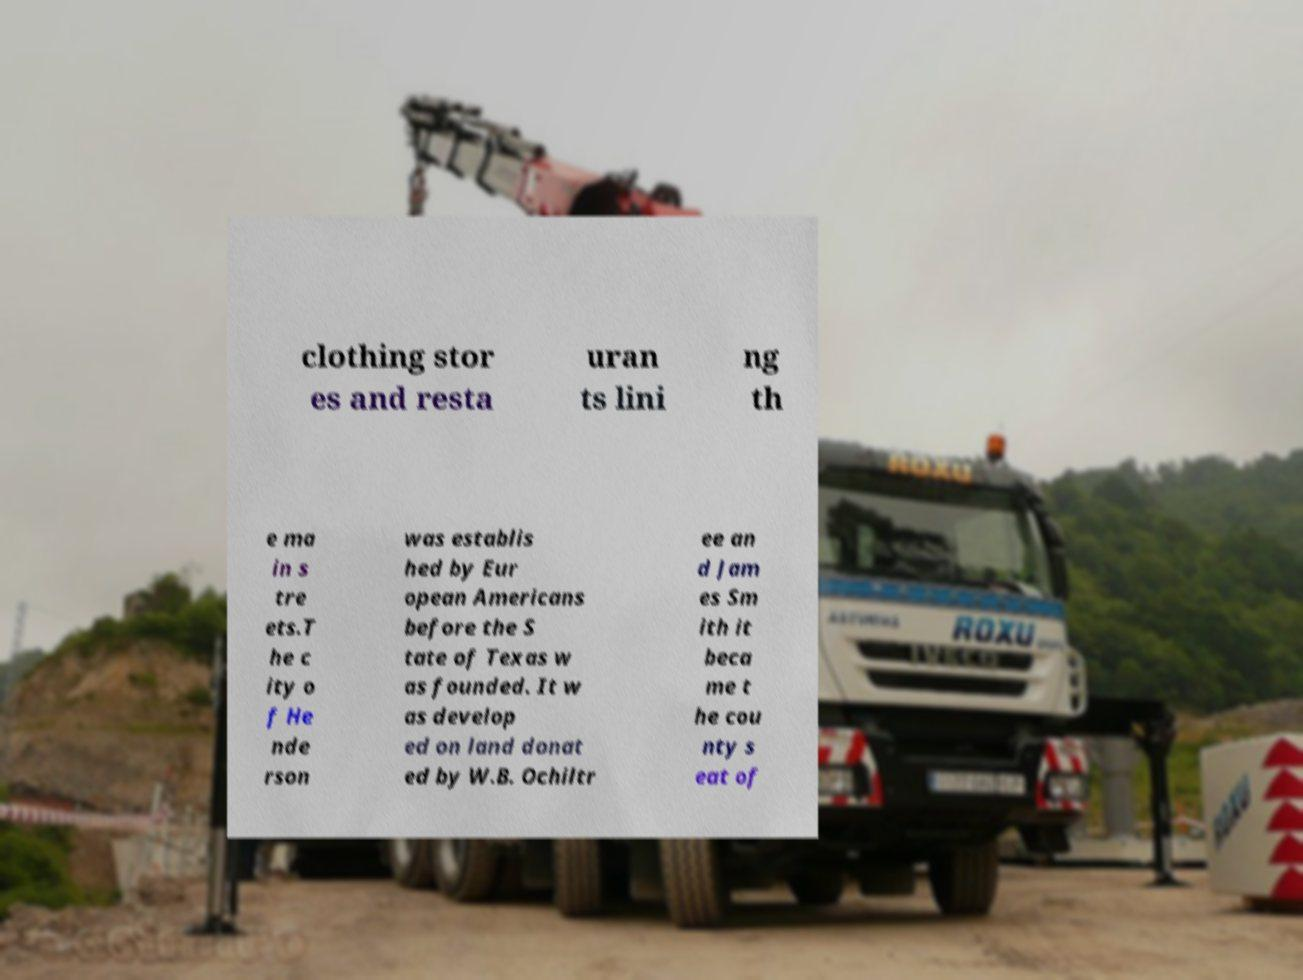For documentation purposes, I need the text within this image transcribed. Could you provide that? clothing stor es and resta uran ts lini ng th e ma in s tre ets.T he c ity o f He nde rson was establis hed by Eur opean Americans before the S tate of Texas w as founded. It w as develop ed on land donat ed by W.B. Ochiltr ee an d Jam es Sm ith it beca me t he cou nty s eat of 